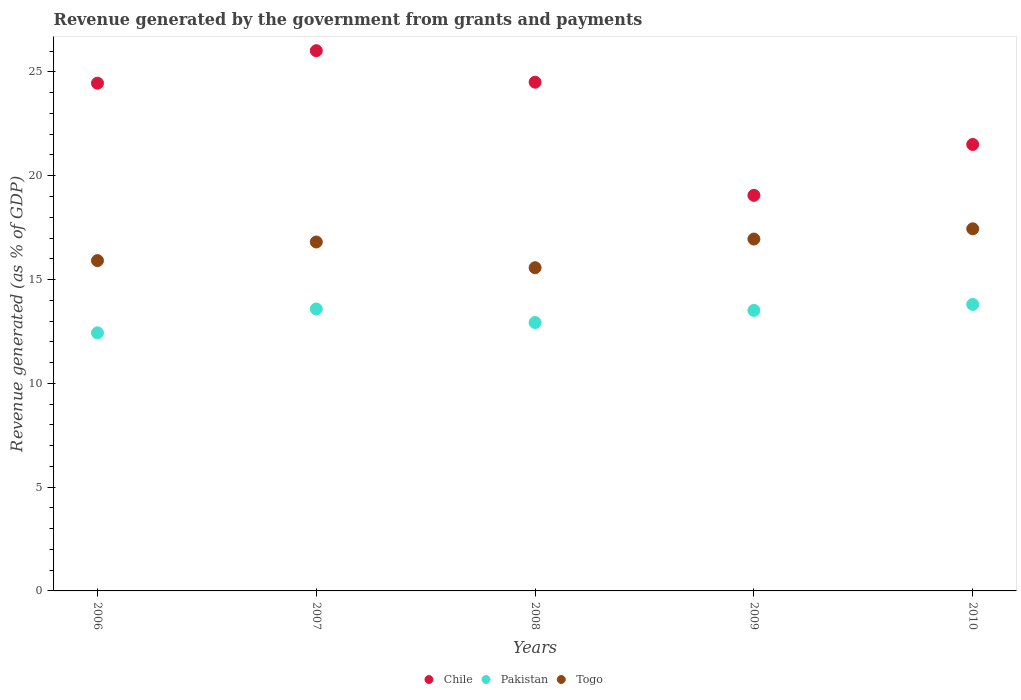What is the revenue generated by the government in Pakistan in 2006?
Your answer should be compact. 12.43. Across all years, what is the maximum revenue generated by the government in Pakistan?
Ensure brevity in your answer.  13.8. Across all years, what is the minimum revenue generated by the government in Togo?
Offer a terse response. 15.57. In which year was the revenue generated by the government in Pakistan minimum?
Provide a short and direct response. 2006. What is the total revenue generated by the government in Chile in the graph?
Give a very brief answer. 115.55. What is the difference between the revenue generated by the government in Togo in 2006 and that in 2009?
Make the answer very short. -1.04. What is the difference between the revenue generated by the government in Chile in 2006 and the revenue generated by the government in Pakistan in 2009?
Your answer should be very brief. 10.95. What is the average revenue generated by the government in Pakistan per year?
Provide a short and direct response. 13.25. In the year 2010, what is the difference between the revenue generated by the government in Togo and revenue generated by the government in Pakistan?
Your answer should be compact. 3.64. In how many years, is the revenue generated by the government in Pakistan greater than 7 %?
Ensure brevity in your answer.  5. What is the ratio of the revenue generated by the government in Chile in 2009 to that in 2010?
Your answer should be very brief. 0.89. What is the difference between the highest and the second highest revenue generated by the government in Chile?
Keep it short and to the point. 1.52. What is the difference between the highest and the lowest revenue generated by the government in Pakistan?
Give a very brief answer. 1.37. In how many years, is the revenue generated by the government in Chile greater than the average revenue generated by the government in Chile taken over all years?
Your answer should be compact. 3. Is the sum of the revenue generated by the government in Chile in 2006 and 2007 greater than the maximum revenue generated by the government in Togo across all years?
Provide a succinct answer. Yes. Is it the case that in every year, the sum of the revenue generated by the government in Pakistan and revenue generated by the government in Chile  is greater than the revenue generated by the government in Togo?
Give a very brief answer. Yes. Does the revenue generated by the government in Chile monotonically increase over the years?
Ensure brevity in your answer.  No. Is the revenue generated by the government in Chile strictly greater than the revenue generated by the government in Togo over the years?
Offer a very short reply. Yes. How many dotlines are there?
Your answer should be very brief. 3. How many years are there in the graph?
Offer a very short reply. 5. Are the values on the major ticks of Y-axis written in scientific E-notation?
Make the answer very short. No. Does the graph contain any zero values?
Make the answer very short. No. Does the graph contain grids?
Provide a short and direct response. No. Where does the legend appear in the graph?
Provide a succinct answer. Bottom center. How are the legend labels stacked?
Your answer should be compact. Horizontal. What is the title of the graph?
Your answer should be compact. Revenue generated by the government from grants and payments. What is the label or title of the Y-axis?
Offer a very short reply. Revenue generated (as % of GDP). What is the Revenue generated (as % of GDP) in Chile in 2006?
Provide a succinct answer. 24.46. What is the Revenue generated (as % of GDP) in Pakistan in 2006?
Keep it short and to the point. 12.43. What is the Revenue generated (as % of GDP) of Togo in 2006?
Your answer should be compact. 15.91. What is the Revenue generated (as % of GDP) in Chile in 2007?
Your response must be concise. 26.02. What is the Revenue generated (as % of GDP) in Pakistan in 2007?
Your response must be concise. 13.58. What is the Revenue generated (as % of GDP) in Togo in 2007?
Your response must be concise. 16.81. What is the Revenue generated (as % of GDP) in Chile in 2008?
Your answer should be very brief. 24.51. What is the Revenue generated (as % of GDP) of Pakistan in 2008?
Your answer should be very brief. 12.93. What is the Revenue generated (as % of GDP) in Togo in 2008?
Offer a terse response. 15.57. What is the Revenue generated (as % of GDP) of Chile in 2009?
Keep it short and to the point. 19.05. What is the Revenue generated (as % of GDP) in Pakistan in 2009?
Offer a very short reply. 13.51. What is the Revenue generated (as % of GDP) in Togo in 2009?
Give a very brief answer. 16.95. What is the Revenue generated (as % of GDP) of Chile in 2010?
Your answer should be compact. 21.51. What is the Revenue generated (as % of GDP) of Pakistan in 2010?
Make the answer very short. 13.8. What is the Revenue generated (as % of GDP) of Togo in 2010?
Your response must be concise. 17.44. Across all years, what is the maximum Revenue generated (as % of GDP) of Chile?
Provide a succinct answer. 26.02. Across all years, what is the maximum Revenue generated (as % of GDP) in Pakistan?
Offer a very short reply. 13.8. Across all years, what is the maximum Revenue generated (as % of GDP) of Togo?
Make the answer very short. 17.44. Across all years, what is the minimum Revenue generated (as % of GDP) in Chile?
Provide a succinct answer. 19.05. Across all years, what is the minimum Revenue generated (as % of GDP) of Pakistan?
Your answer should be compact. 12.43. Across all years, what is the minimum Revenue generated (as % of GDP) of Togo?
Keep it short and to the point. 15.57. What is the total Revenue generated (as % of GDP) in Chile in the graph?
Provide a short and direct response. 115.55. What is the total Revenue generated (as % of GDP) of Pakistan in the graph?
Ensure brevity in your answer.  66.26. What is the total Revenue generated (as % of GDP) in Togo in the graph?
Your response must be concise. 82.68. What is the difference between the Revenue generated (as % of GDP) of Chile in 2006 and that in 2007?
Offer a very short reply. -1.57. What is the difference between the Revenue generated (as % of GDP) in Pakistan in 2006 and that in 2007?
Your answer should be compact. -1.15. What is the difference between the Revenue generated (as % of GDP) in Togo in 2006 and that in 2007?
Make the answer very short. -0.9. What is the difference between the Revenue generated (as % of GDP) in Chile in 2006 and that in 2008?
Your answer should be compact. -0.05. What is the difference between the Revenue generated (as % of GDP) in Pakistan in 2006 and that in 2008?
Provide a succinct answer. -0.5. What is the difference between the Revenue generated (as % of GDP) in Togo in 2006 and that in 2008?
Keep it short and to the point. 0.34. What is the difference between the Revenue generated (as % of GDP) of Chile in 2006 and that in 2009?
Ensure brevity in your answer.  5.4. What is the difference between the Revenue generated (as % of GDP) of Pakistan in 2006 and that in 2009?
Offer a very short reply. -1.08. What is the difference between the Revenue generated (as % of GDP) of Togo in 2006 and that in 2009?
Keep it short and to the point. -1.04. What is the difference between the Revenue generated (as % of GDP) in Chile in 2006 and that in 2010?
Give a very brief answer. 2.95. What is the difference between the Revenue generated (as % of GDP) of Pakistan in 2006 and that in 2010?
Give a very brief answer. -1.37. What is the difference between the Revenue generated (as % of GDP) in Togo in 2006 and that in 2010?
Provide a succinct answer. -1.53. What is the difference between the Revenue generated (as % of GDP) of Chile in 2007 and that in 2008?
Your answer should be compact. 1.52. What is the difference between the Revenue generated (as % of GDP) of Pakistan in 2007 and that in 2008?
Ensure brevity in your answer.  0.65. What is the difference between the Revenue generated (as % of GDP) of Togo in 2007 and that in 2008?
Give a very brief answer. 1.24. What is the difference between the Revenue generated (as % of GDP) in Chile in 2007 and that in 2009?
Your response must be concise. 6.97. What is the difference between the Revenue generated (as % of GDP) of Pakistan in 2007 and that in 2009?
Give a very brief answer. 0.07. What is the difference between the Revenue generated (as % of GDP) of Togo in 2007 and that in 2009?
Ensure brevity in your answer.  -0.14. What is the difference between the Revenue generated (as % of GDP) in Chile in 2007 and that in 2010?
Keep it short and to the point. 4.52. What is the difference between the Revenue generated (as % of GDP) of Pakistan in 2007 and that in 2010?
Give a very brief answer. -0.22. What is the difference between the Revenue generated (as % of GDP) of Togo in 2007 and that in 2010?
Offer a very short reply. -0.64. What is the difference between the Revenue generated (as % of GDP) in Chile in 2008 and that in 2009?
Keep it short and to the point. 5.45. What is the difference between the Revenue generated (as % of GDP) of Pakistan in 2008 and that in 2009?
Offer a very short reply. -0.58. What is the difference between the Revenue generated (as % of GDP) in Togo in 2008 and that in 2009?
Your answer should be compact. -1.38. What is the difference between the Revenue generated (as % of GDP) of Chile in 2008 and that in 2010?
Provide a succinct answer. 3. What is the difference between the Revenue generated (as % of GDP) in Pakistan in 2008 and that in 2010?
Provide a succinct answer. -0.87. What is the difference between the Revenue generated (as % of GDP) in Togo in 2008 and that in 2010?
Make the answer very short. -1.87. What is the difference between the Revenue generated (as % of GDP) in Chile in 2009 and that in 2010?
Keep it short and to the point. -2.45. What is the difference between the Revenue generated (as % of GDP) of Pakistan in 2009 and that in 2010?
Provide a succinct answer. -0.29. What is the difference between the Revenue generated (as % of GDP) in Togo in 2009 and that in 2010?
Give a very brief answer. -0.49. What is the difference between the Revenue generated (as % of GDP) of Chile in 2006 and the Revenue generated (as % of GDP) of Pakistan in 2007?
Give a very brief answer. 10.88. What is the difference between the Revenue generated (as % of GDP) in Chile in 2006 and the Revenue generated (as % of GDP) in Togo in 2007?
Ensure brevity in your answer.  7.65. What is the difference between the Revenue generated (as % of GDP) of Pakistan in 2006 and the Revenue generated (as % of GDP) of Togo in 2007?
Give a very brief answer. -4.38. What is the difference between the Revenue generated (as % of GDP) of Chile in 2006 and the Revenue generated (as % of GDP) of Pakistan in 2008?
Your answer should be very brief. 11.53. What is the difference between the Revenue generated (as % of GDP) in Chile in 2006 and the Revenue generated (as % of GDP) in Togo in 2008?
Keep it short and to the point. 8.89. What is the difference between the Revenue generated (as % of GDP) of Pakistan in 2006 and the Revenue generated (as % of GDP) of Togo in 2008?
Your answer should be compact. -3.14. What is the difference between the Revenue generated (as % of GDP) of Chile in 2006 and the Revenue generated (as % of GDP) of Pakistan in 2009?
Offer a terse response. 10.95. What is the difference between the Revenue generated (as % of GDP) in Chile in 2006 and the Revenue generated (as % of GDP) in Togo in 2009?
Ensure brevity in your answer.  7.51. What is the difference between the Revenue generated (as % of GDP) in Pakistan in 2006 and the Revenue generated (as % of GDP) in Togo in 2009?
Provide a succinct answer. -4.52. What is the difference between the Revenue generated (as % of GDP) of Chile in 2006 and the Revenue generated (as % of GDP) of Pakistan in 2010?
Provide a short and direct response. 10.66. What is the difference between the Revenue generated (as % of GDP) of Chile in 2006 and the Revenue generated (as % of GDP) of Togo in 2010?
Your answer should be very brief. 7.02. What is the difference between the Revenue generated (as % of GDP) in Pakistan in 2006 and the Revenue generated (as % of GDP) in Togo in 2010?
Offer a terse response. -5.01. What is the difference between the Revenue generated (as % of GDP) of Chile in 2007 and the Revenue generated (as % of GDP) of Pakistan in 2008?
Give a very brief answer. 13.1. What is the difference between the Revenue generated (as % of GDP) of Chile in 2007 and the Revenue generated (as % of GDP) of Togo in 2008?
Your response must be concise. 10.46. What is the difference between the Revenue generated (as % of GDP) in Pakistan in 2007 and the Revenue generated (as % of GDP) in Togo in 2008?
Keep it short and to the point. -1.99. What is the difference between the Revenue generated (as % of GDP) in Chile in 2007 and the Revenue generated (as % of GDP) in Pakistan in 2009?
Provide a short and direct response. 12.51. What is the difference between the Revenue generated (as % of GDP) of Chile in 2007 and the Revenue generated (as % of GDP) of Togo in 2009?
Give a very brief answer. 9.07. What is the difference between the Revenue generated (as % of GDP) of Pakistan in 2007 and the Revenue generated (as % of GDP) of Togo in 2009?
Provide a succinct answer. -3.37. What is the difference between the Revenue generated (as % of GDP) of Chile in 2007 and the Revenue generated (as % of GDP) of Pakistan in 2010?
Your response must be concise. 12.22. What is the difference between the Revenue generated (as % of GDP) in Chile in 2007 and the Revenue generated (as % of GDP) in Togo in 2010?
Offer a terse response. 8.58. What is the difference between the Revenue generated (as % of GDP) in Pakistan in 2007 and the Revenue generated (as % of GDP) in Togo in 2010?
Make the answer very short. -3.86. What is the difference between the Revenue generated (as % of GDP) of Chile in 2008 and the Revenue generated (as % of GDP) of Pakistan in 2009?
Your answer should be very brief. 10.99. What is the difference between the Revenue generated (as % of GDP) of Chile in 2008 and the Revenue generated (as % of GDP) of Togo in 2009?
Your answer should be compact. 7.56. What is the difference between the Revenue generated (as % of GDP) in Pakistan in 2008 and the Revenue generated (as % of GDP) in Togo in 2009?
Give a very brief answer. -4.02. What is the difference between the Revenue generated (as % of GDP) of Chile in 2008 and the Revenue generated (as % of GDP) of Pakistan in 2010?
Your answer should be very brief. 10.7. What is the difference between the Revenue generated (as % of GDP) in Chile in 2008 and the Revenue generated (as % of GDP) in Togo in 2010?
Offer a very short reply. 7.06. What is the difference between the Revenue generated (as % of GDP) in Pakistan in 2008 and the Revenue generated (as % of GDP) in Togo in 2010?
Provide a succinct answer. -4.52. What is the difference between the Revenue generated (as % of GDP) in Chile in 2009 and the Revenue generated (as % of GDP) in Pakistan in 2010?
Keep it short and to the point. 5.25. What is the difference between the Revenue generated (as % of GDP) in Chile in 2009 and the Revenue generated (as % of GDP) in Togo in 2010?
Your response must be concise. 1.61. What is the difference between the Revenue generated (as % of GDP) in Pakistan in 2009 and the Revenue generated (as % of GDP) in Togo in 2010?
Your response must be concise. -3.93. What is the average Revenue generated (as % of GDP) of Chile per year?
Offer a terse response. 23.11. What is the average Revenue generated (as % of GDP) of Pakistan per year?
Your response must be concise. 13.25. What is the average Revenue generated (as % of GDP) in Togo per year?
Provide a short and direct response. 16.54. In the year 2006, what is the difference between the Revenue generated (as % of GDP) in Chile and Revenue generated (as % of GDP) in Pakistan?
Offer a very short reply. 12.03. In the year 2006, what is the difference between the Revenue generated (as % of GDP) of Chile and Revenue generated (as % of GDP) of Togo?
Give a very brief answer. 8.55. In the year 2006, what is the difference between the Revenue generated (as % of GDP) of Pakistan and Revenue generated (as % of GDP) of Togo?
Keep it short and to the point. -3.48. In the year 2007, what is the difference between the Revenue generated (as % of GDP) of Chile and Revenue generated (as % of GDP) of Pakistan?
Offer a terse response. 12.44. In the year 2007, what is the difference between the Revenue generated (as % of GDP) of Chile and Revenue generated (as % of GDP) of Togo?
Offer a very short reply. 9.22. In the year 2007, what is the difference between the Revenue generated (as % of GDP) of Pakistan and Revenue generated (as % of GDP) of Togo?
Provide a short and direct response. -3.23. In the year 2008, what is the difference between the Revenue generated (as % of GDP) of Chile and Revenue generated (as % of GDP) of Pakistan?
Give a very brief answer. 11.58. In the year 2008, what is the difference between the Revenue generated (as % of GDP) in Chile and Revenue generated (as % of GDP) in Togo?
Your answer should be very brief. 8.94. In the year 2008, what is the difference between the Revenue generated (as % of GDP) in Pakistan and Revenue generated (as % of GDP) in Togo?
Your answer should be compact. -2.64. In the year 2009, what is the difference between the Revenue generated (as % of GDP) in Chile and Revenue generated (as % of GDP) in Pakistan?
Keep it short and to the point. 5.54. In the year 2009, what is the difference between the Revenue generated (as % of GDP) in Chile and Revenue generated (as % of GDP) in Togo?
Ensure brevity in your answer.  2.1. In the year 2009, what is the difference between the Revenue generated (as % of GDP) of Pakistan and Revenue generated (as % of GDP) of Togo?
Provide a short and direct response. -3.44. In the year 2010, what is the difference between the Revenue generated (as % of GDP) in Chile and Revenue generated (as % of GDP) in Pakistan?
Make the answer very short. 7.71. In the year 2010, what is the difference between the Revenue generated (as % of GDP) in Chile and Revenue generated (as % of GDP) in Togo?
Provide a short and direct response. 4.06. In the year 2010, what is the difference between the Revenue generated (as % of GDP) in Pakistan and Revenue generated (as % of GDP) in Togo?
Give a very brief answer. -3.64. What is the ratio of the Revenue generated (as % of GDP) in Chile in 2006 to that in 2007?
Provide a succinct answer. 0.94. What is the ratio of the Revenue generated (as % of GDP) in Pakistan in 2006 to that in 2007?
Ensure brevity in your answer.  0.92. What is the ratio of the Revenue generated (as % of GDP) of Togo in 2006 to that in 2007?
Give a very brief answer. 0.95. What is the ratio of the Revenue generated (as % of GDP) of Chile in 2006 to that in 2008?
Your response must be concise. 1. What is the ratio of the Revenue generated (as % of GDP) in Pakistan in 2006 to that in 2008?
Keep it short and to the point. 0.96. What is the ratio of the Revenue generated (as % of GDP) in Chile in 2006 to that in 2009?
Your response must be concise. 1.28. What is the ratio of the Revenue generated (as % of GDP) in Pakistan in 2006 to that in 2009?
Your answer should be compact. 0.92. What is the ratio of the Revenue generated (as % of GDP) of Togo in 2006 to that in 2009?
Provide a short and direct response. 0.94. What is the ratio of the Revenue generated (as % of GDP) of Chile in 2006 to that in 2010?
Offer a very short reply. 1.14. What is the ratio of the Revenue generated (as % of GDP) in Pakistan in 2006 to that in 2010?
Offer a very short reply. 0.9. What is the ratio of the Revenue generated (as % of GDP) of Togo in 2006 to that in 2010?
Provide a short and direct response. 0.91. What is the ratio of the Revenue generated (as % of GDP) in Chile in 2007 to that in 2008?
Make the answer very short. 1.06. What is the ratio of the Revenue generated (as % of GDP) in Pakistan in 2007 to that in 2008?
Your answer should be compact. 1.05. What is the ratio of the Revenue generated (as % of GDP) in Togo in 2007 to that in 2008?
Your response must be concise. 1.08. What is the ratio of the Revenue generated (as % of GDP) of Chile in 2007 to that in 2009?
Your answer should be very brief. 1.37. What is the ratio of the Revenue generated (as % of GDP) of Chile in 2007 to that in 2010?
Your answer should be compact. 1.21. What is the ratio of the Revenue generated (as % of GDP) of Pakistan in 2007 to that in 2010?
Ensure brevity in your answer.  0.98. What is the ratio of the Revenue generated (as % of GDP) of Togo in 2007 to that in 2010?
Keep it short and to the point. 0.96. What is the ratio of the Revenue generated (as % of GDP) in Chile in 2008 to that in 2009?
Provide a short and direct response. 1.29. What is the ratio of the Revenue generated (as % of GDP) in Pakistan in 2008 to that in 2009?
Provide a short and direct response. 0.96. What is the ratio of the Revenue generated (as % of GDP) in Togo in 2008 to that in 2009?
Give a very brief answer. 0.92. What is the ratio of the Revenue generated (as % of GDP) of Chile in 2008 to that in 2010?
Provide a short and direct response. 1.14. What is the ratio of the Revenue generated (as % of GDP) in Pakistan in 2008 to that in 2010?
Make the answer very short. 0.94. What is the ratio of the Revenue generated (as % of GDP) in Togo in 2008 to that in 2010?
Offer a terse response. 0.89. What is the ratio of the Revenue generated (as % of GDP) in Chile in 2009 to that in 2010?
Provide a short and direct response. 0.89. What is the ratio of the Revenue generated (as % of GDP) of Togo in 2009 to that in 2010?
Your answer should be very brief. 0.97. What is the difference between the highest and the second highest Revenue generated (as % of GDP) of Chile?
Keep it short and to the point. 1.52. What is the difference between the highest and the second highest Revenue generated (as % of GDP) in Pakistan?
Make the answer very short. 0.22. What is the difference between the highest and the second highest Revenue generated (as % of GDP) of Togo?
Your answer should be very brief. 0.49. What is the difference between the highest and the lowest Revenue generated (as % of GDP) of Chile?
Make the answer very short. 6.97. What is the difference between the highest and the lowest Revenue generated (as % of GDP) of Pakistan?
Your answer should be compact. 1.37. What is the difference between the highest and the lowest Revenue generated (as % of GDP) of Togo?
Offer a very short reply. 1.87. 